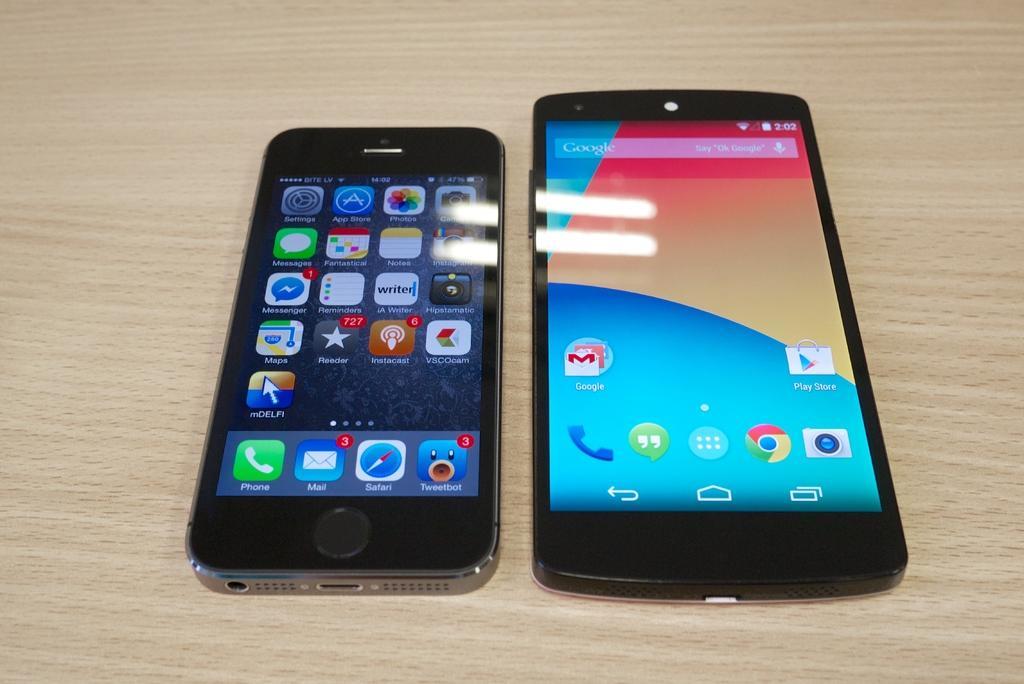Describe this image in one or two sentences. In this picture I can see couple of mobile phones on the table. 